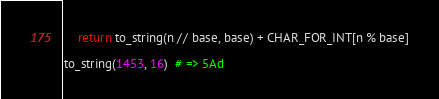Convert code to text. <code><loc_0><loc_0><loc_500><loc_500><_Python_>    return to_string(n // base, base) + CHAR_FOR_INT[n % base]

to_string(1453, 16)  # => 5Ad
</code> 